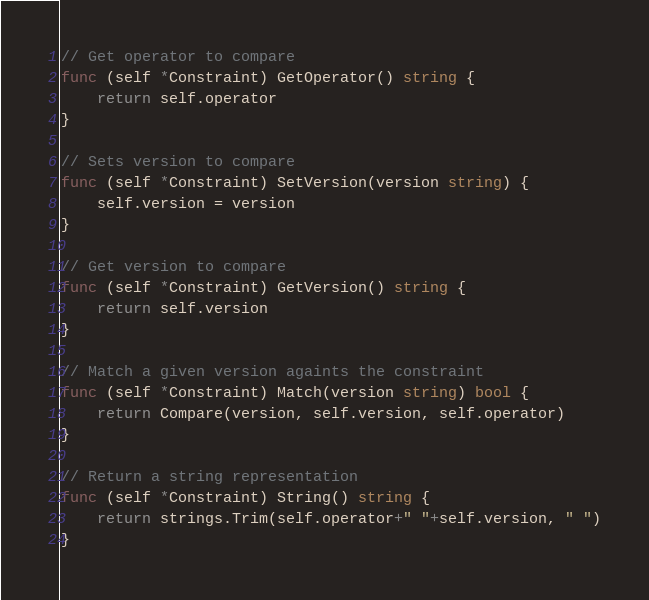<code> <loc_0><loc_0><loc_500><loc_500><_Go_>
// Get operator to compare
func (self *Constraint) GetOperator() string {
	return self.operator
}

// Sets version to compare
func (self *Constraint) SetVersion(version string) {
	self.version = version
}

// Get version to compare
func (self *Constraint) GetVersion() string {
	return self.version
}

// Match a given version againts the constraint
func (self *Constraint) Match(version string) bool {
	return Compare(version, self.version, self.operator)
}

// Return a string representation
func (self *Constraint) String() string {
	return strings.Trim(self.operator+" "+self.version, " ")
}
</code> 